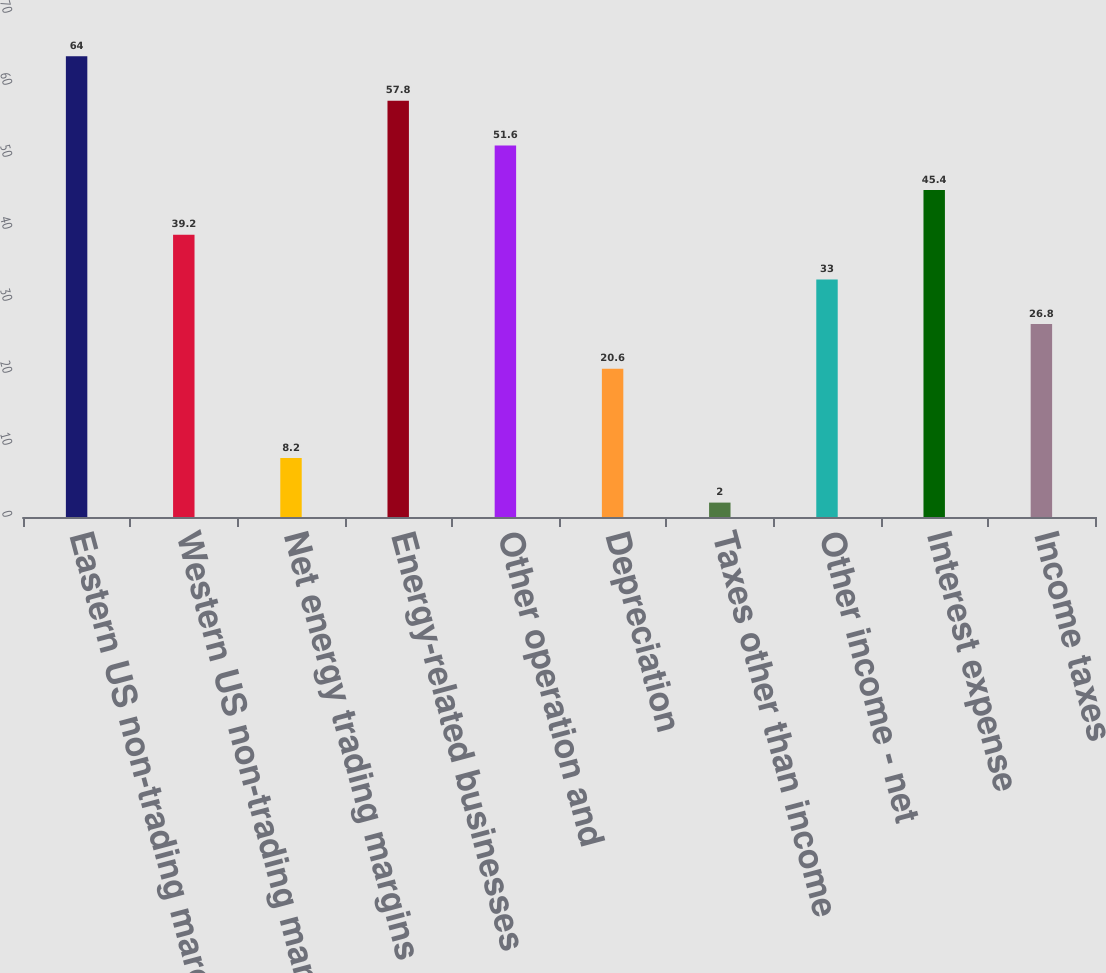Convert chart to OTSL. <chart><loc_0><loc_0><loc_500><loc_500><bar_chart><fcel>Eastern US non-trading margins<fcel>Western US non-trading margins<fcel>Net energy trading margins<fcel>Energy-related businesses<fcel>Other operation and<fcel>Depreciation<fcel>Taxes other than income<fcel>Other income - net<fcel>Interest expense<fcel>Income taxes<nl><fcel>64<fcel>39.2<fcel>8.2<fcel>57.8<fcel>51.6<fcel>20.6<fcel>2<fcel>33<fcel>45.4<fcel>26.8<nl></chart> 